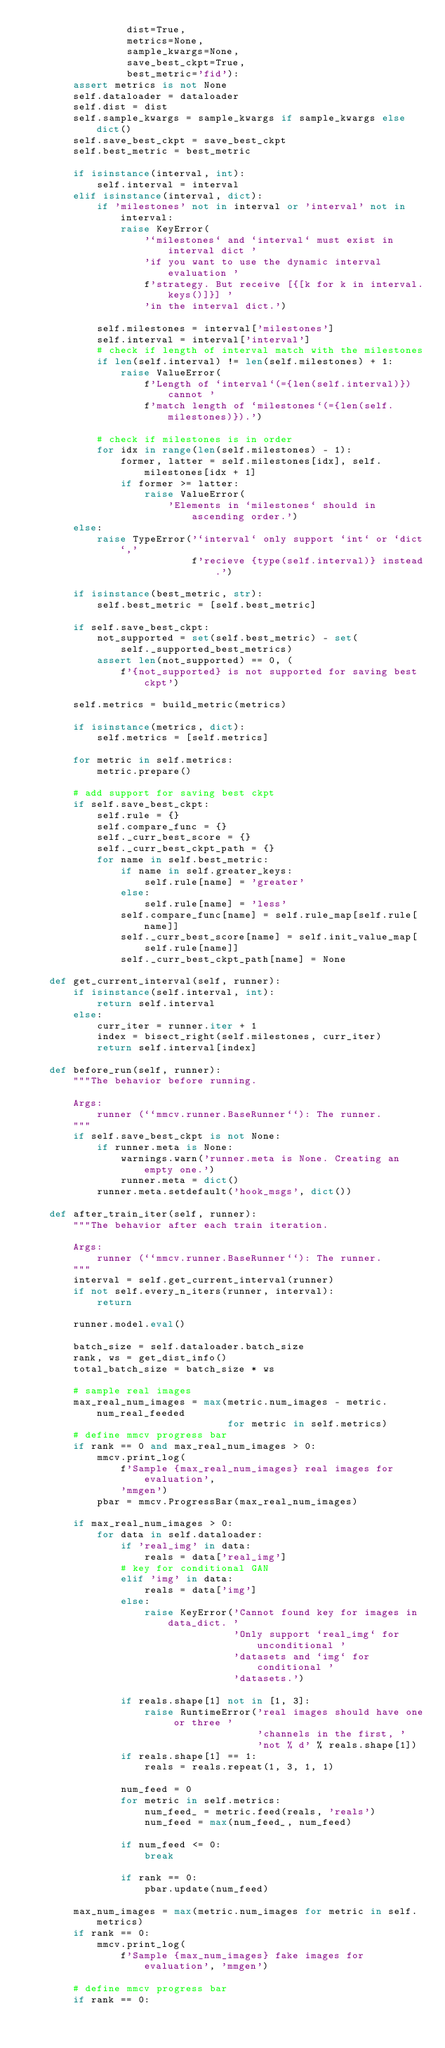<code> <loc_0><loc_0><loc_500><loc_500><_Python_>                 dist=True,
                 metrics=None,
                 sample_kwargs=None,
                 save_best_ckpt=True,
                 best_metric='fid'):
        assert metrics is not None
        self.dataloader = dataloader
        self.dist = dist
        self.sample_kwargs = sample_kwargs if sample_kwargs else dict()
        self.save_best_ckpt = save_best_ckpt
        self.best_metric = best_metric

        if isinstance(interval, int):
            self.interval = interval
        elif isinstance(interval, dict):
            if 'milestones' not in interval or 'interval' not in interval:
                raise KeyError(
                    '`milestones` and `interval` must exist in interval dict '
                    'if you want to use the dynamic interval evaluation '
                    f'strategy. But receive [{[k for k in interval.keys()]}] '
                    'in the interval dict.')

            self.milestones = interval['milestones']
            self.interval = interval['interval']
            # check if length of interval match with the milestones
            if len(self.interval) != len(self.milestones) + 1:
                raise ValueError(
                    f'Length of `interval`(={len(self.interval)}) cannot '
                    f'match length of `milestones`(={len(self.milestones)}).')

            # check if milestones is in order
            for idx in range(len(self.milestones) - 1):
                former, latter = self.milestones[idx], self.milestones[idx + 1]
                if former >= latter:
                    raise ValueError(
                        'Elements in `milestones` should in ascending order.')
        else:
            raise TypeError('`interval` only support `int` or `dict`,'
                            f'recieve {type(self.interval)} instead.')

        if isinstance(best_metric, str):
            self.best_metric = [self.best_metric]

        if self.save_best_ckpt:
            not_supported = set(self.best_metric) - set(
                self._supported_best_metrics)
            assert len(not_supported) == 0, (
                f'{not_supported} is not supported for saving best ckpt')

        self.metrics = build_metric(metrics)

        if isinstance(metrics, dict):
            self.metrics = [self.metrics]

        for metric in self.metrics:
            metric.prepare()

        # add support for saving best ckpt
        if self.save_best_ckpt:
            self.rule = {}
            self.compare_func = {}
            self._curr_best_score = {}
            self._curr_best_ckpt_path = {}
            for name in self.best_metric:
                if name in self.greater_keys:
                    self.rule[name] = 'greater'
                else:
                    self.rule[name] = 'less'
                self.compare_func[name] = self.rule_map[self.rule[name]]
                self._curr_best_score[name] = self.init_value_map[
                    self.rule[name]]
                self._curr_best_ckpt_path[name] = None

    def get_current_interval(self, runner):
        if isinstance(self.interval, int):
            return self.interval
        else:
            curr_iter = runner.iter + 1
            index = bisect_right(self.milestones, curr_iter)
            return self.interval[index]

    def before_run(self, runner):
        """The behavior before running.

        Args:
            runner (``mmcv.runner.BaseRunner``): The runner.
        """
        if self.save_best_ckpt is not None:
            if runner.meta is None:
                warnings.warn('runner.meta is None. Creating an empty one.')
                runner.meta = dict()
            runner.meta.setdefault('hook_msgs', dict())

    def after_train_iter(self, runner):
        """The behavior after each train iteration.

        Args:
            runner (``mmcv.runner.BaseRunner``): The runner.
        """
        interval = self.get_current_interval(runner)
        if not self.every_n_iters(runner, interval):
            return

        runner.model.eval()

        batch_size = self.dataloader.batch_size
        rank, ws = get_dist_info()
        total_batch_size = batch_size * ws

        # sample real images
        max_real_num_images = max(metric.num_images - metric.num_real_feeded
                                  for metric in self.metrics)
        # define mmcv progress bar
        if rank == 0 and max_real_num_images > 0:
            mmcv.print_log(
                f'Sample {max_real_num_images} real images for evaluation',
                'mmgen')
            pbar = mmcv.ProgressBar(max_real_num_images)

        if max_real_num_images > 0:
            for data in self.dataloader:
                if 'real_img' in data:
                    reals = data['real_img']
                # key for conditional GAN
                elif 'img' in data:
                    reals = data['img']
                else:
                    raise KeyError('Cannot found key for images in data_dict. '
                                   'Only support `real_img` for unconditional '
                                   'datasets and `img` for conditional '
                                   'datasets.')

                if reals.shape[1] not in [1, 3]:
                    raise RuntimeError('real images should have one or three '
                                       'channels in the first, '
                                       'not % d' % reals.shape[1])
                if reals.shape[1] == 1:
                    reals = reals.repeat(1, 3, 1, 1)

                num_feed = 0
                for metric in self.metrics:
                    num_feed_ = metric.feed(reals, 'reals')
                    num_feed = max(num_feed_, num_feed)

                if num_feed <= 0:
                    break

                if rank == 0:
                    pbar.update(num_feed)

        max_num_images = max(metric.num_images for metric in self.metrics)
        if rank == 0:
            mmcv.print_log(
                f'Sample {max_num_images} fake images for evaluation', 'mmgen')

        # define mmcv progress bar
        if rank == 0:</code> 